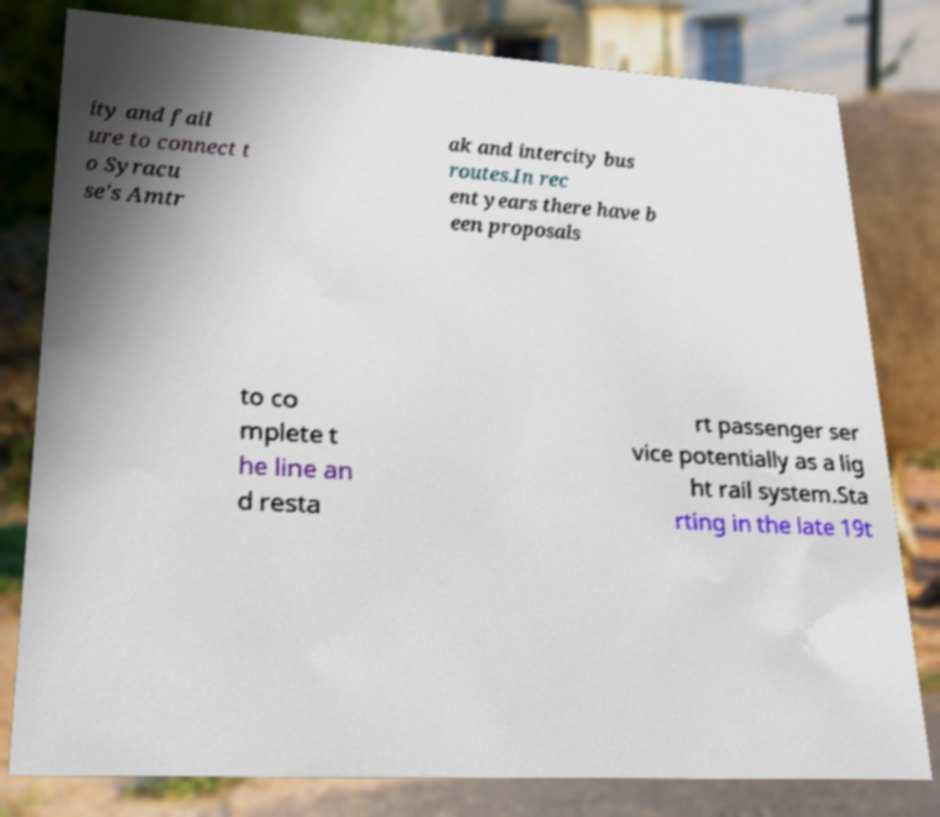Can you read and provide the text displayed in the image?This photo seems to have some interesting text. Can you extract and type it out for me? ity and fail ure to connect t o Syracu se's Amtr ak and intercity bus routes.In rec ent years there have b een proposals to co mplete t he line an d resta rt passenger ser vice potentially as a lig ht rail system.Sta rting in the late 19t 